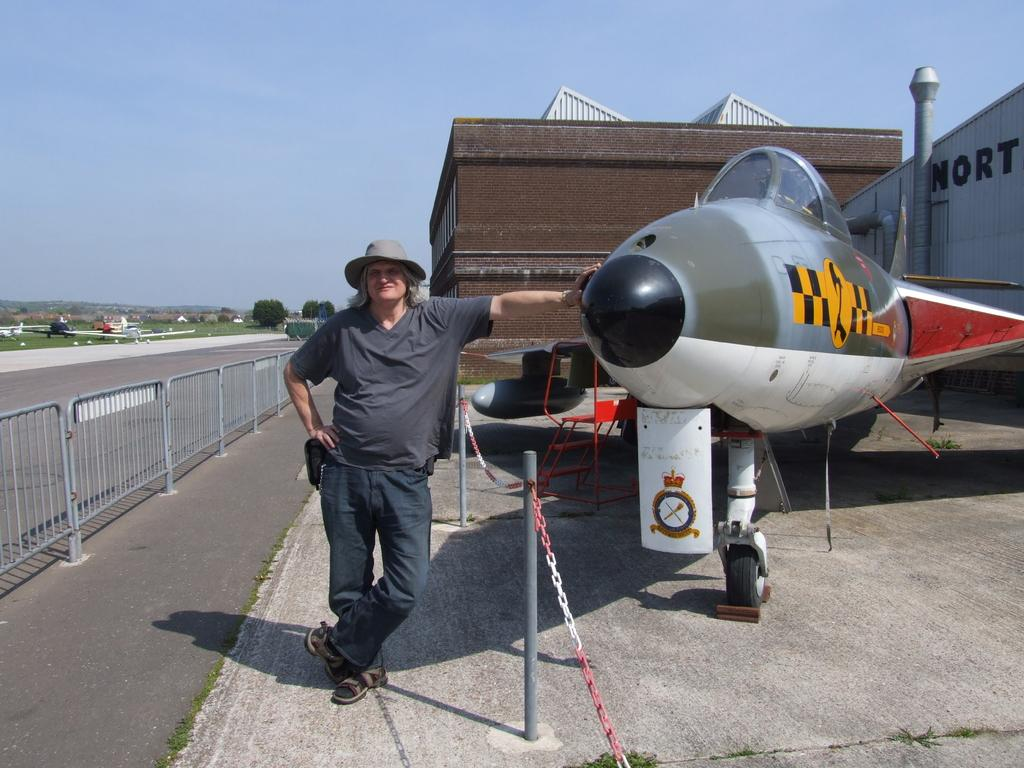<image>
Describe the image concisely. A man stands in front of a jet in front of a building with the letters NORT on its front. 